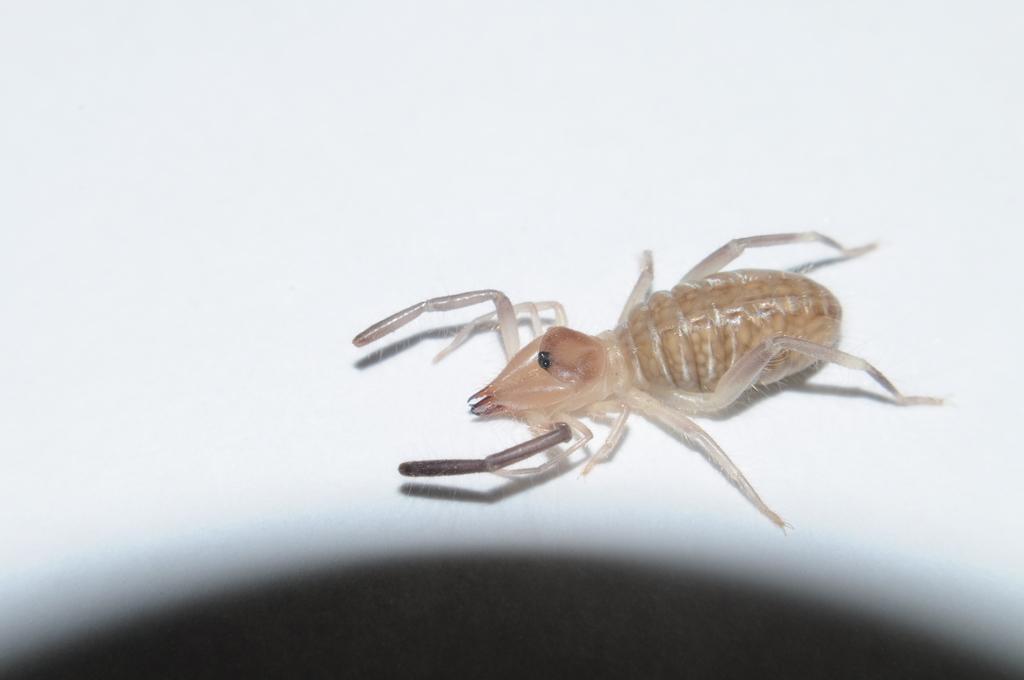Describe this image in one or two sentences. In this image I can see an insect which is on the white surface. The insect is in brown color. 